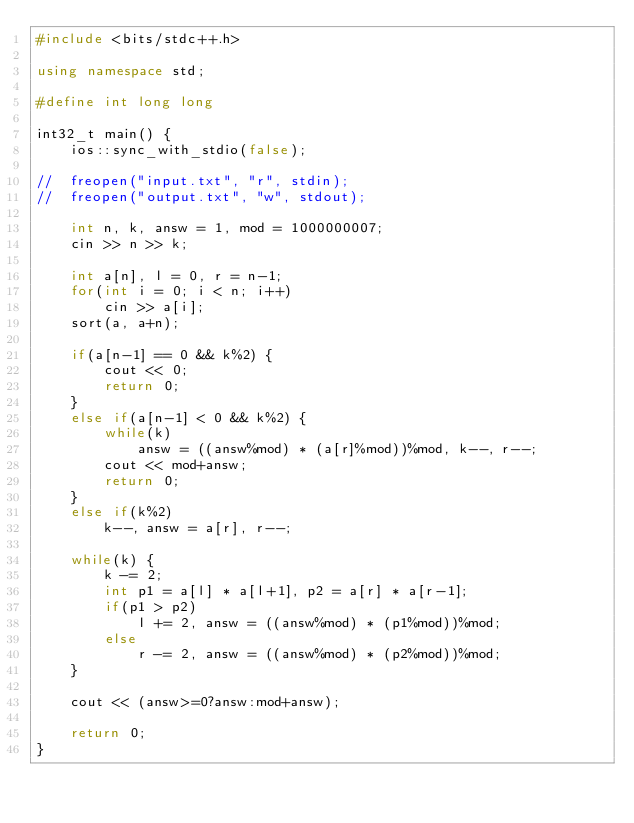Convert code to text. <code><loc_0><loc_0><loc_500><loc_500><_C++_>#include <bits/stdc++.h>

using namespace std;

#define int long long

int32_t main() {
    ios::sync_with_stdio(false);

//  freopen("input.txt", "r", stdin);
//  freopen("output.txt", "w", stdout);

    int n, k, answ = 1, mod = 1000000007;
    cin >> n >> k;

    int a[n], l = 0, r = n-1;
    for(int i = 0; i < n; i++)
        cin >> a[i];
    sort(a, a+n);

    if(a[n-1] == 0 && k%2) {
        cout << 0;
        return 0;
    }
    else if(a[n-1] < 0 && k%2) {
        while(k)
            answ = ((answ%mod) * (a[r]%mod))%mod, k--, r--;
        cout << mod+answ;
        return 0;
    }
    else if(k%2)
        k--, answ = a[r], r--;

    while(k) {
        k -= 2;
        int p1 = a[l] * a[l+1], p2 = a[r] * a[r-1];
        if(p1 > p2)
            l += 2, answ = ((answ%mod) * (p1%mod))%mod;
        else
            r -= 2, answ = ((answ%mod) * (p2%mod))%mod;
    }

    cout << (answ>=0?answ:mod+answ);

    return 0;
}
</code> 